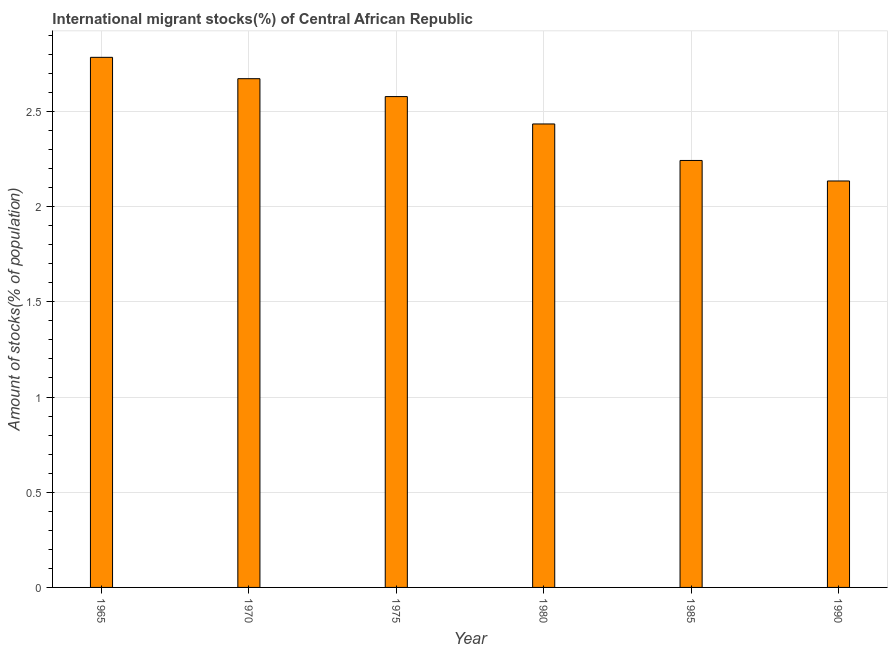Does the graph contain any zero values?
Your answer should be very brief. No. Does the graph contain grids?
Keep it short and to the point. Yes. What is the title of the graph?
Keep it short and to the point. International migrant stocks(%) of Central African Republic. What is the label or title of the X-axis?
Offer a terse response. Year. What is the label or title of the Y-axis?
Provide a succinct answer. Amount of stocks(% of population). What is the number of international migrant stocks in 1975?
Make the answer very short. 2.58. Across all years, what is the maximum number of international migrant stocks?
Ensure brevity in your answer.  2.78. Across all years, what is the minimum number of international migrant stocks?
Ensure brevity in your answer.  2.13. In which year was the number of international migrant stocks maximum?
Offer a terse response. 1965. In which year was the number of international migrant stocks minimum?
Your answer should be very brief. 1990. What is the sum of the number of international migrant stocks?
Offer a terse response. 14.85. What is the difference between the number of international migrant stocks in 1965 and 1970?
Offer a terse response. 0.11. What is the average number of international migrant stocks per year?
Offer a very short reply. 2.47. What is the median number of international migrant stocks?
Keep it short and to the point. 2.51. In how many years, is the number of international migrant stocks greater than 2.5 %?
Make the answer very short. 3. What is the ratio of the number of international migrant stocks in 1975 to that in 1985?
Offer a terse response. 1.15. What is the difference between the highest and the second highest number of international migrant stocks?
Offer a very short reply. 0.11. Is the sum of the number of international migrant stocks in 1975 and 1980 greater than the maximum number of international migrant stocks across all years?
Make the answer very short. Yes. What is the difference between the highest and the lowest number of international migrant stocks?
Provide a short and direct response. 0.65. How many bars are there?
Offer a terse response. 6. How many years are there in the graph?
Your answer should be compact. 6. What is the difference between two consecutive major ticks on the Y-axis?
Your answer should be very brief. 0.5. What is the Amount of stocks(% of population) of 1965?
Provide a succinct answer. 2.78. What is the Amount of stocks(% of population) in 1970?
Provide a succinct answer. 2.67. What is the Amount of stocks(% of population) of 1975?
Your response must be concise. 2.58. What is the Amount of stocks(% of population) in 1980?
Your response must be concise. 2.43. What is the Amount of stocks(% of population) of 1985?
Offer a very short reply. 2.24. What is the Amount of stocks(% of population) in 1990?
Your response must be concise. 2.13. What is the difference between the Amount of stocks(% of population) in 1965 and 1970?
Your response must be concise. 0.11. What is the difference between the Amount of stocks(% of population) in 1965 and 1975?
Offer a terse response. 0.21. What is the difference between the Amount of stocks(% of population) in 1965 and 1980?
Your answer should be very brief. 0.35. What is the difference between the Amount of stocks(% of population) in 1965 and 1985?
Your response must be concise. 0.54. What is the difference between the Amount of stocks(% of population) in 1965 and 1990?
Offer a very short reply. 0.65. What is the difference between the Amount of stocks(% of population) in 1970 and 1975?
Your answer should be very brief. 0.09. What is the difference between the Amount of stocks(% of population) in 1970 and 1980?
Provide a short and direct response. 0.24. What is the difference between the Amount of stocks(% of population) in 1970 and 1985?
Provide a short and direct response. 0.43. What is the difference between the Amount of stocks(% of population) in 1970 and 1990?
Offer a terse response. 0.54. What is the difference between the Amount of stocks(% of population) in 1975 and 1980?
Keep it short and to the point. 0.14. What is the difference between the Amount of stocks(% of population) in 1975 and 1985?
Keep it short and to the point. 0.34. What is the difference between the Amount of stocks(% of population) in 1975 and 1990?
Offer a very short reply. 0.44. What is the difference between the Amount of stocks(% of population) in 1980 and 1985?
Your answer should be compact. 0.19. What is the difference between the Amount of stocks(% of population) in 1980 and 1990?
Your response must be concise. 0.3. What is the difference between the Amount of stocks(% of population) in 1985 and 1990?
Make the answer very short. 0.11. What is the ratio of the Amount of stocks(% of population) in 1965 to that in 1970?
Keep it short and to the point. 1.04. What is the ratio of the Amount of stocks(% of population) in 1965 to that in 1975?
Your answer should be compact. 1.08. What is the ratio of the Amount of stocks(% of population) in 1965 to that in 1980?
Keep it short and to the point. 1.14. What is the ratio of the Amount of stocks(% of population) in 1965 to that in 1985?
Provide a succinct answer. 1.24. What is the ratio of the Amount of stocks(% of population) in 1965 to that in 1990?
Offer a very short reply. 1.3. What is the ratio of the Amount of stocks(% of population) in 1970 to that in 1975?
Provide a succinct answer. 1.04. What is the ratio of the Amount of stocks(% of population) in 1970 to that in 1980?
Provide a short and direct response. 1.1. What is the ratio of the Amount of stocks(% of population) in 1970 to that in 1985?
Provide a short and direct response. 1.19. What is the ratio of the Amount of stocks(% of population) in 1970 to that in 1990?
Your response must be concise. 1.25. What is the ratio of the Amount of stocks(% of population) in 1975 to that in 1980?
Give a very brief answer. 1.06. What is the ratio of the Amount of stocks(% of population) in 1975 to that in 1985?
Provide a short and direct response. 1.15. What is the ratio of the Amount of stocks(% of population) in 1975 to that in 1990?
Keep it short and to the point. 1.21. What is the ratio of the Amount of stocks(% of population) in 1980 to that in 1985?
Your response must be concise. 1.08. What is the ratio of the Amount of stocks(% of population) in 1980 to that in 1990?
Give a very brief answer. 1.14. 